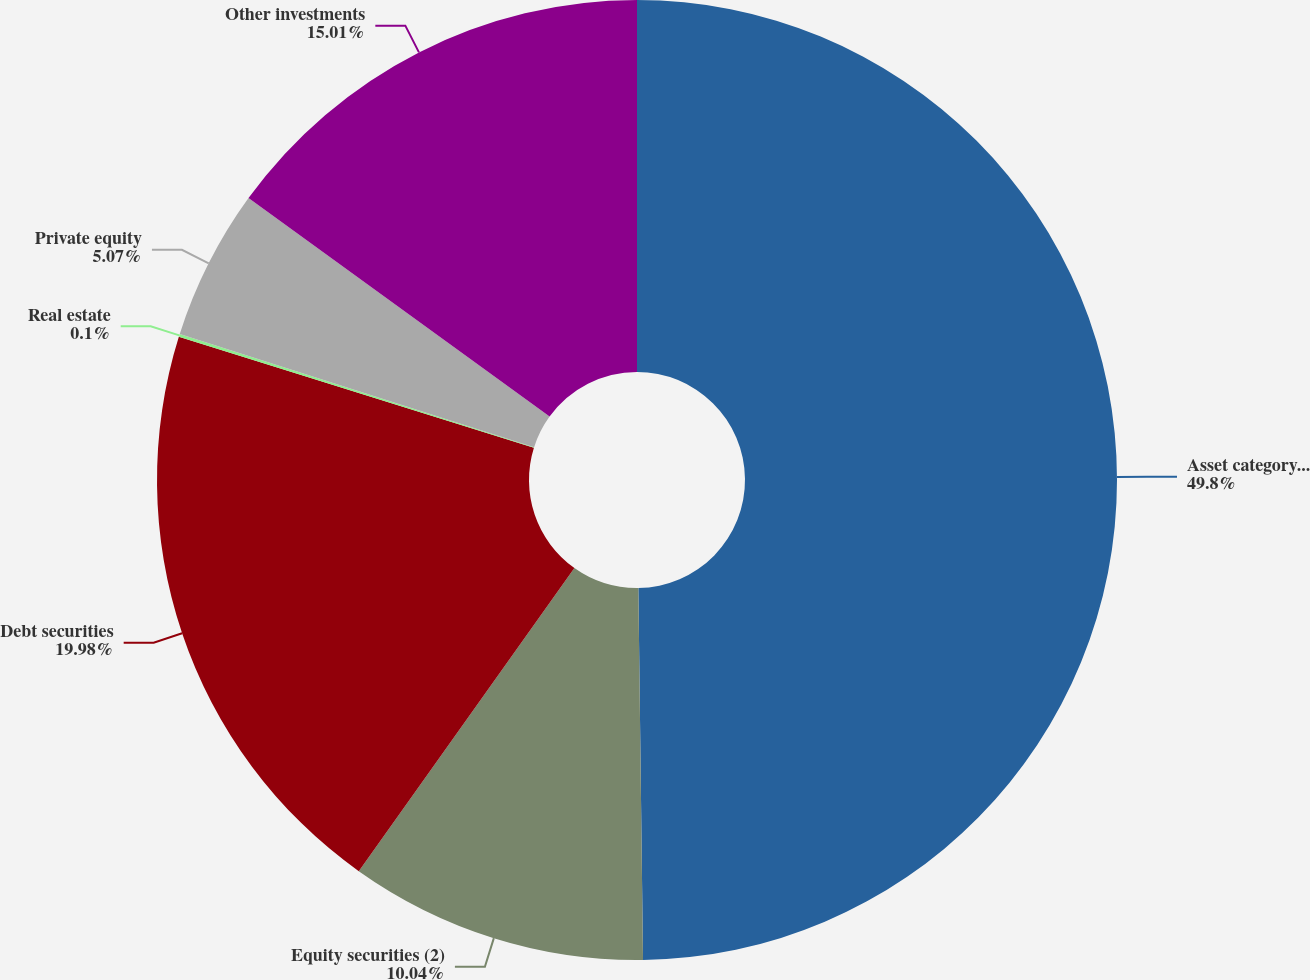Convert chart to OTSL. <chart><loc_0><loc_0><loc_500><loc_500><pie_chart><fcel>Asset category (1)<fcel>Equity securities (2)<fcel>Debt securities<fcel>Real estate<fcel>Private equity<fcel>Other investments<nl><fcel>49.8%<fcel>10.04%<fcel>19.98%<fcel>0.1%<fcel>5.07%<fcel>15.01%<nl></chart> 